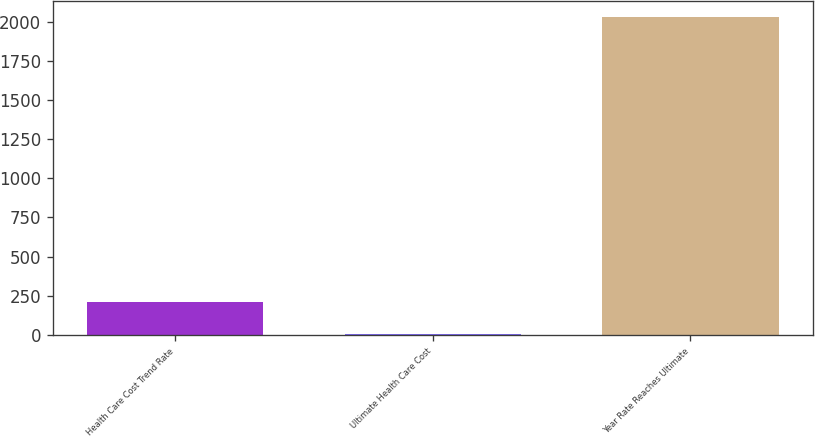<chart> <loc_0><loc_0><loc_500><loc_500><bar_chart><fcel>Health Care Cost Trend Rate<fcel>Ultimate Health Care Cost<fcel>Year Rate Reaches Ultimate<nl><fcel>207.05<fcel>4.5<fcel>2030<nl></chart> 